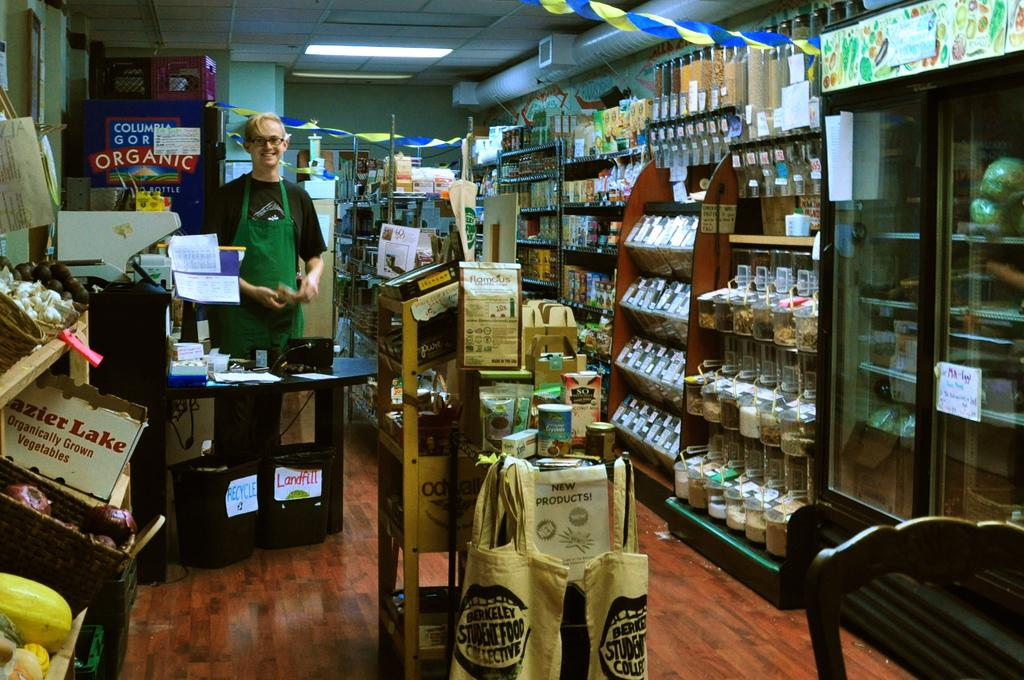<image>
Offer a succinct explanation of the picture presented. Inside a small market with a man smiling by the register and a small stand with brown bags hanging says Berkeley Student Food Collective 